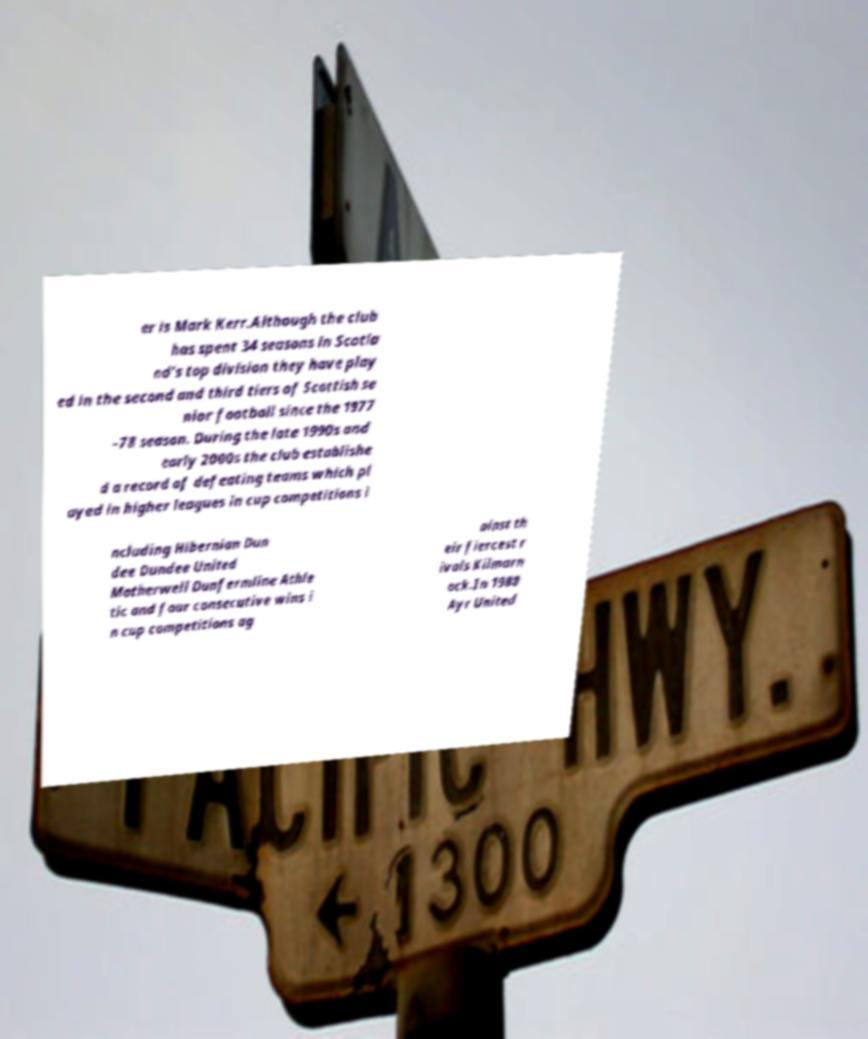Please identify and transcribe the text found in this image. er is Mark Kerr.Although the club has spent 34 seasons in Scotla nd's top division they have play ed in the second and third tiers of Scottish se nior football since the 1977 –78 season. During the late 1990s and early 2000s the club establishe d a record of defeating teams which pl ayed in higher leagues in cup competitions i ncluding Hibernian Dun dee Dundee United Motherwell Dunfermline Athle tic and four consecutive wins i n cup competitions ag ainst th eir fiercest r ivals Kilmarn ock.In 1988 Ayr United 